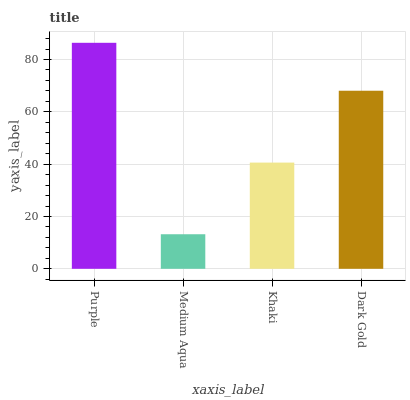Is Medium Aqua the minimum?
Answer yes or no. Yes. Is Purple the maximum?
Answer yes or no. Yes. Is Khaki the minimum?
Answer yes or no. No. Is Khaki the maximum?
Answer yes or no. No. Is Khaki greater than Medium Aqua?
Answer yes or no. Yes. Is Medium Aqua less than Khaki?
Answer yes or no. Yes. Is Medium Aqua greater than Khaki?
Answer yes or no. No. Is Khaki less than Medium Aqua?
Answer yes or no. No. Is Dark Gold the high median?
Answer yes or no. Yes. Is Khaki the low median?
Answer yes or no. Yes. Is Medium Aqua the high median?
Answer yes or no. No. Is Purple the low median?
Answer yes or no. No. 